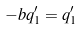Convert formula to latex. <formula><loc_0><loc_0><loc_500><loc_500>- b q ^ { \prime } _ { 1 } = q ^ { \prime } _ { 1 }</formula> 